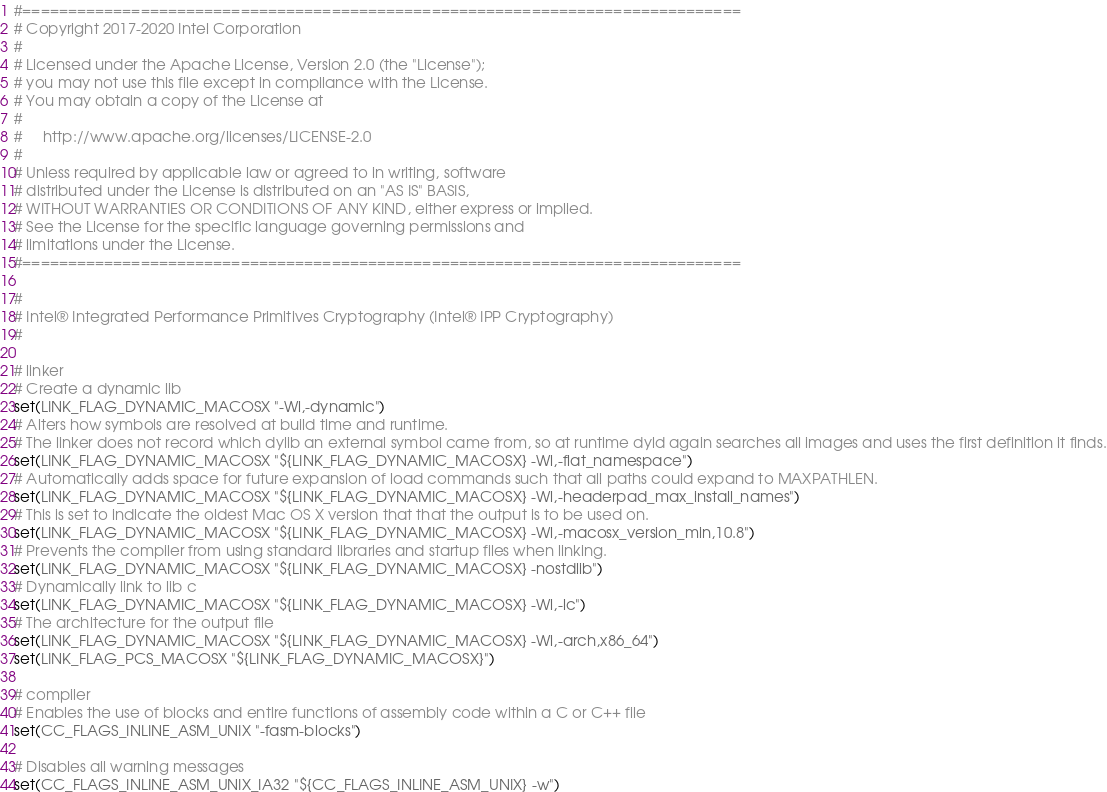Convert code to text. <code><loc_0><loc_0><loc_500><loc_500><_CMake_>#===============================================================================
# Copyright 2017-2020 Intel Corporation
#
# Licensed under the Apache License, Version 2.0 (the "License");
# you may not use this file except in compliance with the License.
# You may obtain a copy of the License at
#
#     http://www.apache.org/licenses/LICENSE-2.0
#
# Unless required by applicable law or agreed to in writing, software
# distributed under the License is distributed on an "AS IS" BASIS,
# WITHOUT WARRANTIES OR CONDITIONS OF ANY KIND, either express or implied.
# See the License for the specific language governing permissions and
# limitations under the License.
#===============================================================================

#
# Intel® Integrated Performance Primitives Cryptography (Intel® IPP Cryptography)
#

# linker
# Create a dynamic lib
set(LINK_FLAG_DYNAMIC_MACOSX "-Wl,-dynamic")
# Alters how symbols are resolved at build time and runtime.
# The linker does not record which dylib an external symbol came from, so at runtime dyld again searches all images and uses the first definition it finds.
set(LINK_FLAG_DYNAMIC_MACOSX "${LINK_FLAG_DYNAMIC_MACOSX} -Wl,-flat_namespace")
# Automatically adds space for future expansion of load commands such that all paths could expand to MAXPATHLEN.
set(LINK_FLAG_DYNAMIC_MACOSX "${LINK_FLAG_DYNAMIC_MACOSX} -Wl,-headerpad_max_install_names")
# This is set to indicate the oldest Mac OS X version that that the output is to be used on.
set(LINK_FLAG_DYNAMIC_MACOSX "${LINK_FLAG_DYNAMIC_MACOSX} -Wl,-macosx_version_min,10.8")
# Prevents the compiler from using standard libraries and startup files when linking.
set(LINK_FLAG_DYNAMIC_MACOSX "${LINK_FLAG_DYNAMIC_MACOSX} -nostdlib")
# Dynamically link to lib c
set(LINK_FLAG_DYNAMIC_MACOSX "${LINK_FLAG_DYNAMIC_MACOSX} -Wl,-lc")
# The architecture for the output file
set(LINK_FLAG_DYNAMIC_MACOSX "${LINK_FLAG_DYNAMIC_MACOSX} -Wl,-arch,x86_64")
set(LINK_FLAG_PCS_MACOSX "${LINK_FLAG_DYNAMIC_MACOSX}")

# compiler
# Enables the use of blocks and entire functions of assembly code within a C or C++ file
set(CC_FLAGS_INLINE_ASM_UNIX "-fasm-blocks")

# Disables all warning messages
set(CC_FLAGS_INLINE_ASM_UNIX_IA32 "${CC_FLAGS_INLINE_ASM_UNIX} -w")</code> 